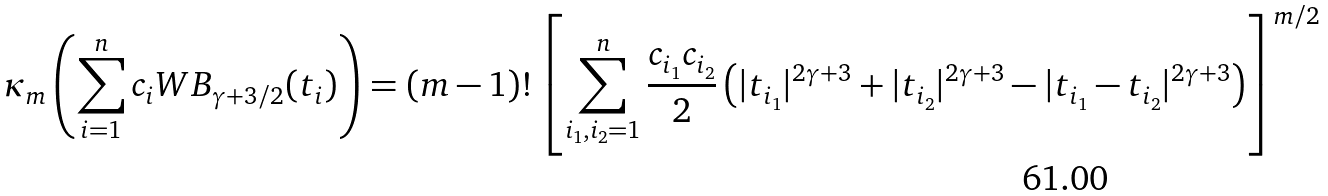<formula> <loc_0><loc_0><loc_500><loc_500>\kappa _ { m } \left ( \sum _ { i = 1 } ^ { n } c _ { i } W B _ { \gamma + 3 / 2 } ( t _ { i } ) \right ) = ( m - 1 ) ! \left [ \sum _ { i _ { 1 } , i _ { 2 } = 1 } ^ { n } \frac { c _ { i _ { 1 } } c _ { i _ { 2 } } } { 2 } \left ( | t _ { i _ { 1 } } | ^ { 2 \gamma + 3 } + | t _ { i _ { 2 } } | ^ { 2 \gamma + 3 } - | t _ { i _ { 1 } } - t _ { i _ { 2 } } | ^ { 2 \gamma + 3 } \right ) \right ] ^ { m / 2 }</formula> 